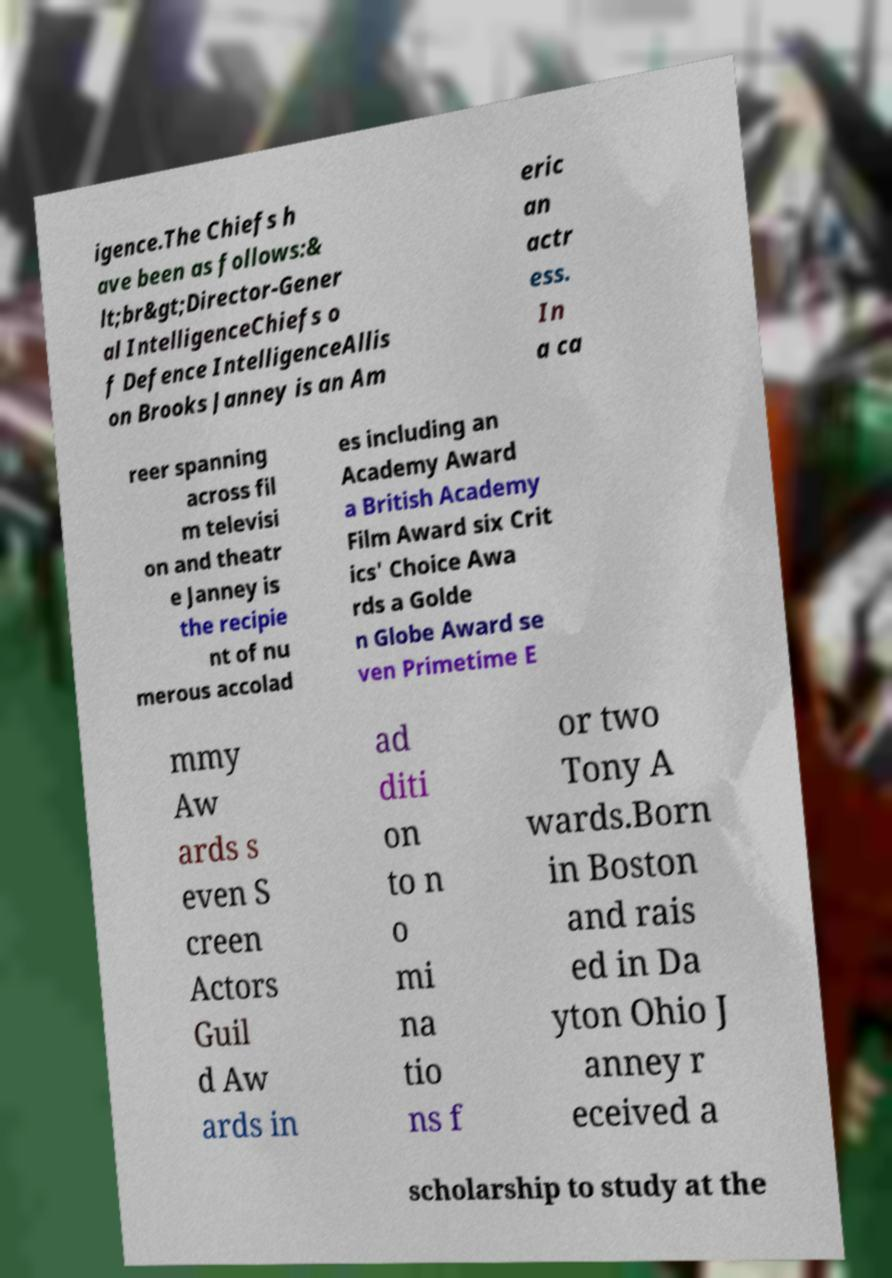Please read and relay the text visible in this image. What does it say? igence.The Chiefs h ave been as follows:& lt;br&gt;Director-Gener al IntelligenceChiefs o f Defence IntelligenceAllis on Brooks Janney is an Am eric an actr ess. In a ca reer spanning across fil m televisi on and theatr e Janney is the recipie nt of nu merous accolad es including an Academy Award a British Academy Film Award six Crit ics' Choice Awa rds a Golde n Globe Award se ven Primetime E mmy Aw ards s even S creen Actors Guil d Aw ards in ad diti on to n o mi na tio ns f or two Tony A wards.Born in Boston and rais ed in Da yton Ohio J anney r eceived a scholarship to study at the 